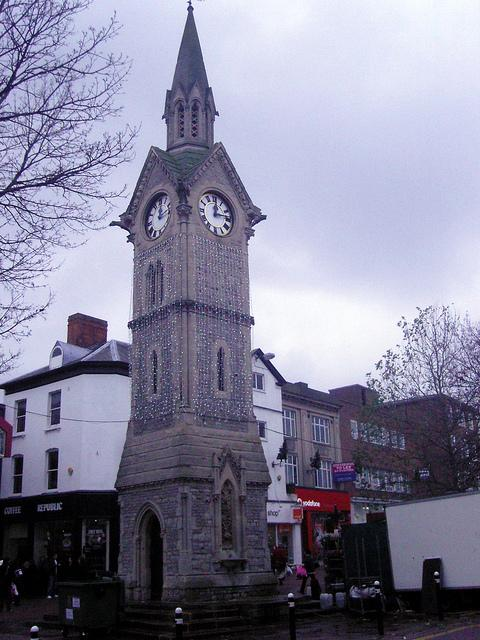What is near the apex of the tower?

Choices:
A) clock
B) serpent
C) eagle
D) statue clock 